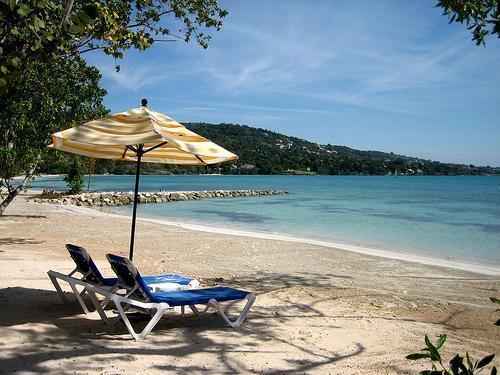How many chairs are there?
Give a very brief answer. 2. 